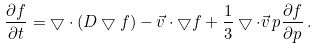Convert formula to latex. <formula><loc_0><loc_0><loc_500><loc_500>\frac { \partial f } { \partial t } = \bigtriangledown \cdot ( D \bigtriangledown f ) - \vec { v } \cdot \bigtriangledown f + \frac { 1 } { 3 } \bigtriangledown \cdot \vec { v } \, p \frac { \partial f } { \partial p } \, .</formula> 